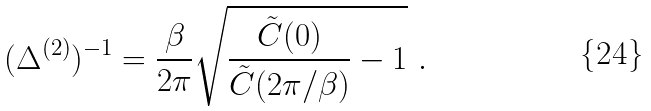<formula> <loc_0><loc_0><loc_500><loc_500>( \Delta ^ { ( 2 ) } ) ^ { - 1 } = \frac { \beta } { 2 \pi } \sqrt { \frac { \tilde { C } ( 0 ) } { \tilde { C } ( 2 \pi / \beta ) } - 1 } \ .</formula> 